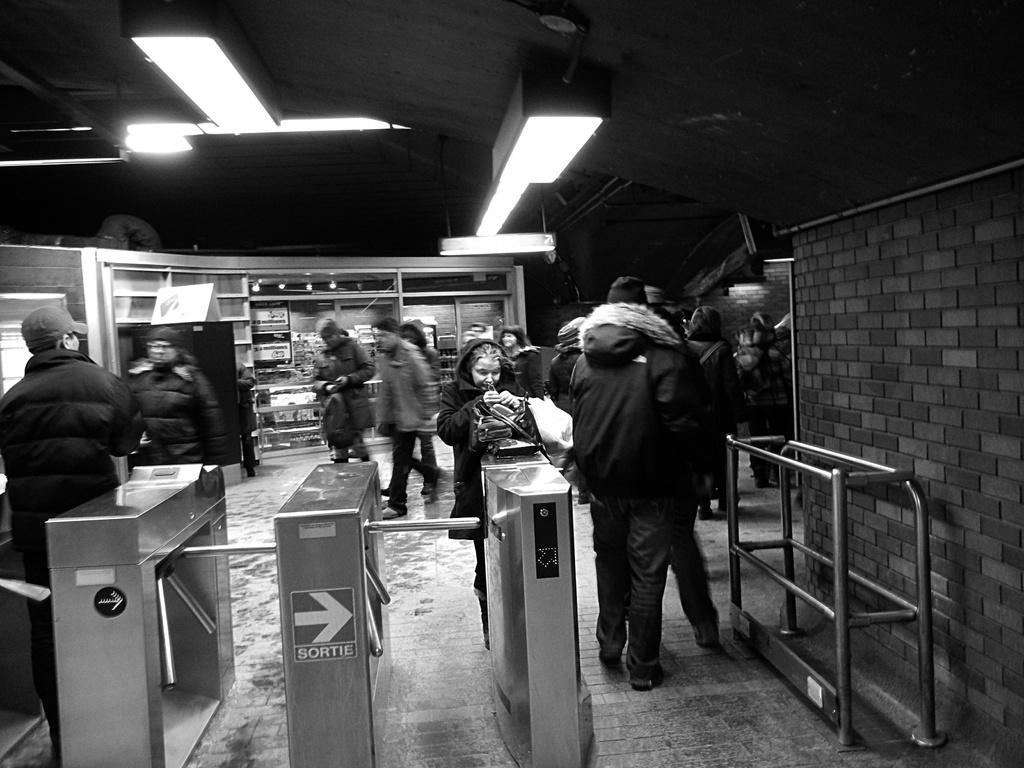Please provide a concise description of this image. This image is a black and white image. This image is taken indoors. At the bottom of the image there is a floor. At the top of the image there is a ceiling with a few lights. On the right side of the image there is a wall and there are a few iron bars. In the background there is a wall and there are a few things. In the middle of the image many people are standing and a few are walking and there is a entrance gate. 